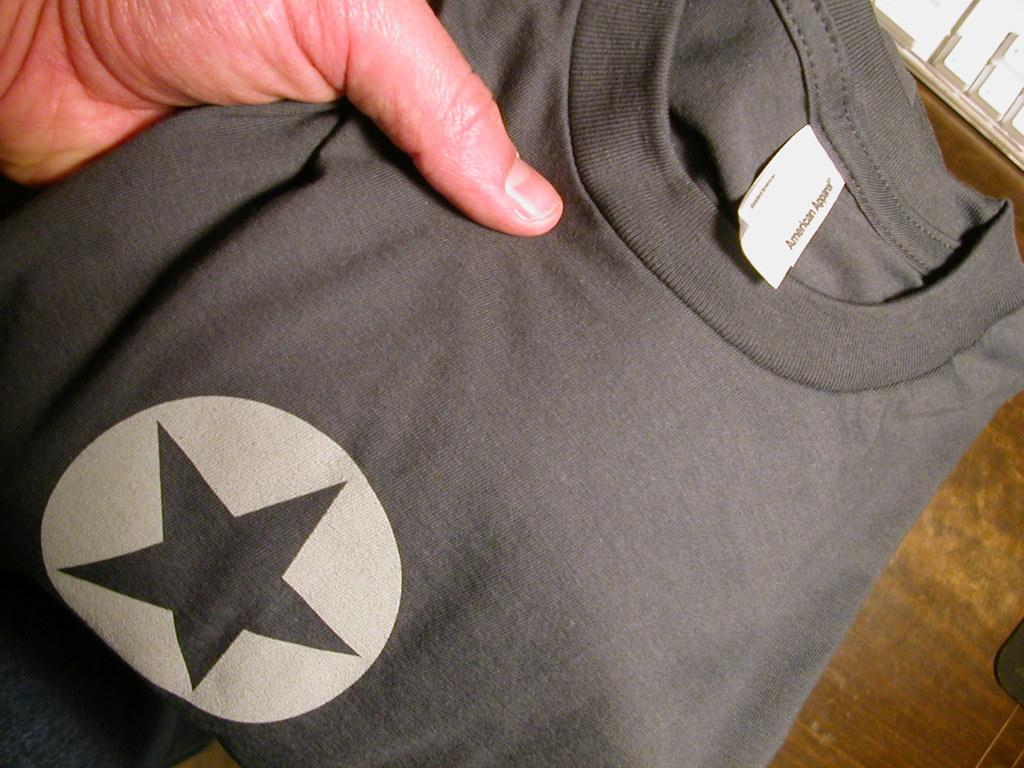What part of a person can be seen in the image? There is a hand of a person in the image. What is the hand holding? The hand is holding a t-shirt. What type of pets can be seen in the image? There are no pets visible in the image; it only shows a hand holding a t-shirt. 